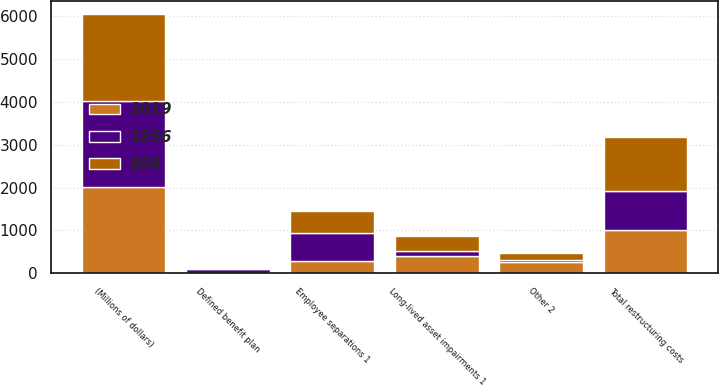Convert chart to OTSL. <chart><loc_0><loc_0><loc_500><loc_500><stacked_bar_chart><ecel><fcel>(Millions of dollars)<fcel>Employee separations 1<fcel>Long-lived asset impairments 1<fcel>Defined benefit plan<fcel>Other 2<fcel>Total restructuring costs<nl><fcel>898<fcel>2017<fcel>525<fcel>346<fcel>29<fcel>173<fcel>1256<nl><fcel>1019<fcel>2016<fcel>297<fcel>391<fcel>7<fcel>262<fcel>1019<nl><fcel>1256<fcel>2015<fcel>641<fcel>127<fcel>82<fcel>48<fcel>898<nl></chart> 